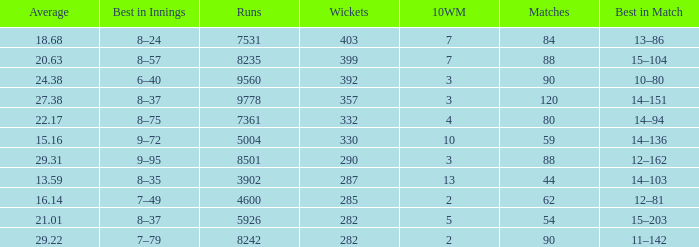What is the sum of runs that are associated with 10WM values over 13? None. 